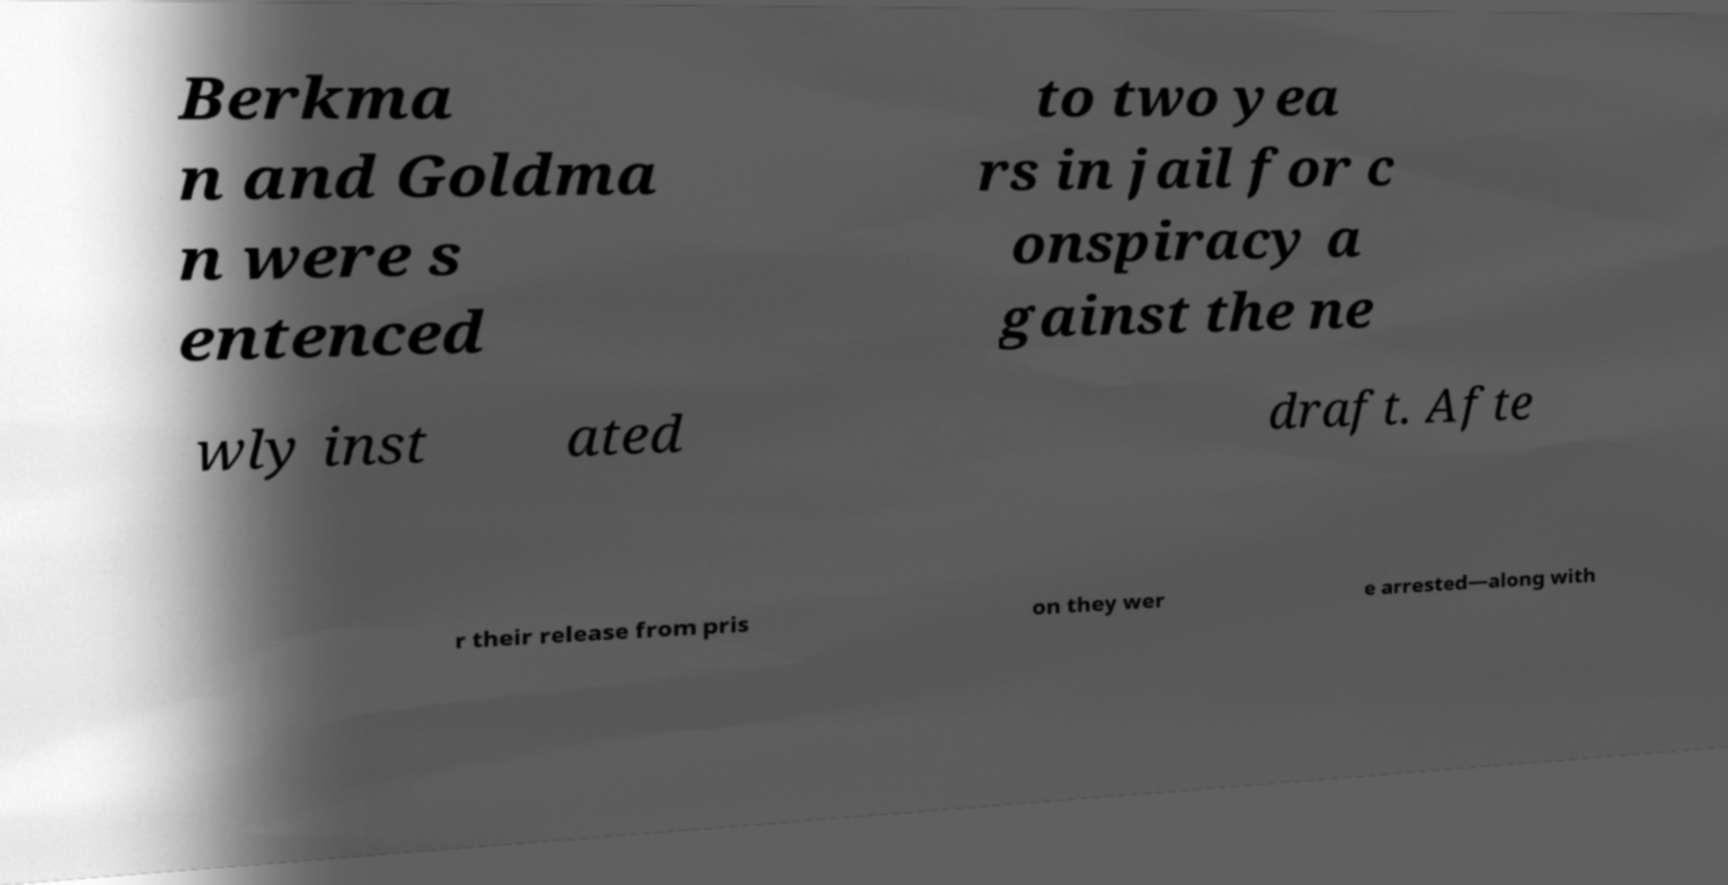Could you extract and type out the text from this image? Berkma n and Goldma n were s entenced to two yea rs in jail for c onspiracy a gainst the ne wly inst ated draft. Afte r their release from pris on they wer e arrested—along with 